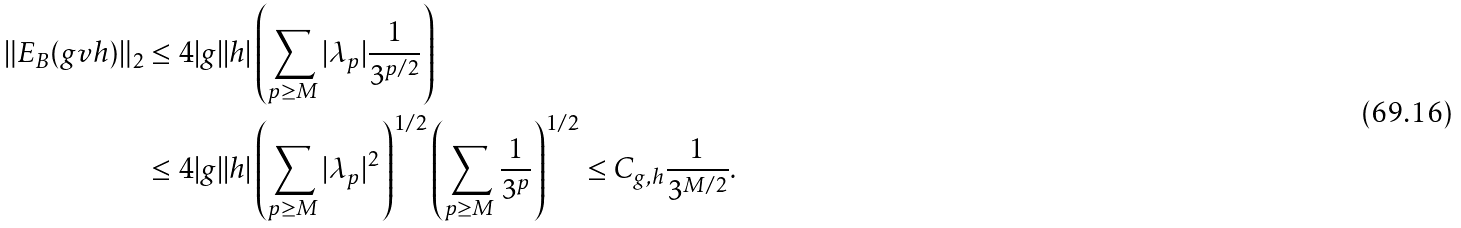<formula> <loc_0><loc_0><loc_500><loc_500>\| E _ { B } ( g v h ) \| _ { 2 } & \leq 4 | g | | h | \left ( \sum _ { p \geq M } | \lambda _ { p } | \frac { 1 } { 3 ^ { p / 2 } } \right ) \\ & \leq 4 | g | | h | \left ( \sum _ { p \geq M } | \lambda _ { p } | ^ { 2 } \right ) ^ { 1 / 2 } \left ( \sum _ { p \geq M } \frac { 1 } { 3 ^ { p } } \right ) ^ { 1 / 2 } \leq C _ { g , h } \frac { 1 } { 3 ^ { M / 2 } } .</formula> 